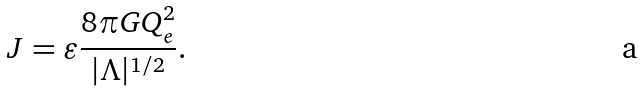<formula> <loc_0><loc_0><loc_500><loc_500>J = \varepsilon \frac { 8 { \pi } G Q _ { e } ^ { 2 } } { | \Lambda | ^ { 1 / 2 } } .</formula> 